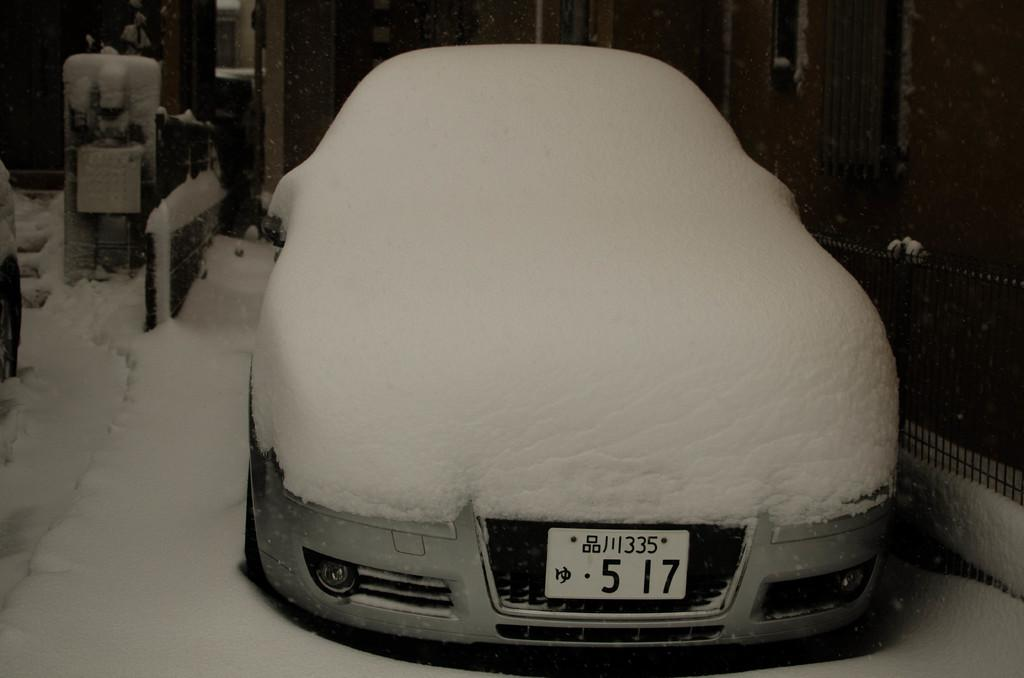<image>
Render a clear and concise summary of the photo. A gray car with Chinese letters on the license plate is covered completely with  snow. 